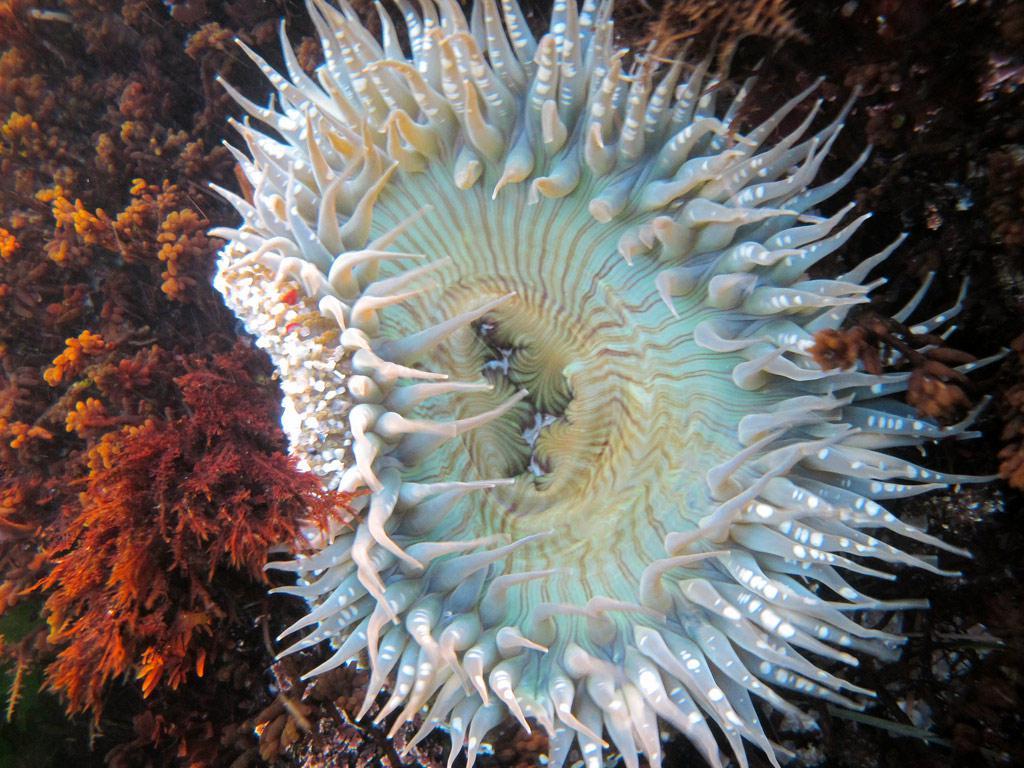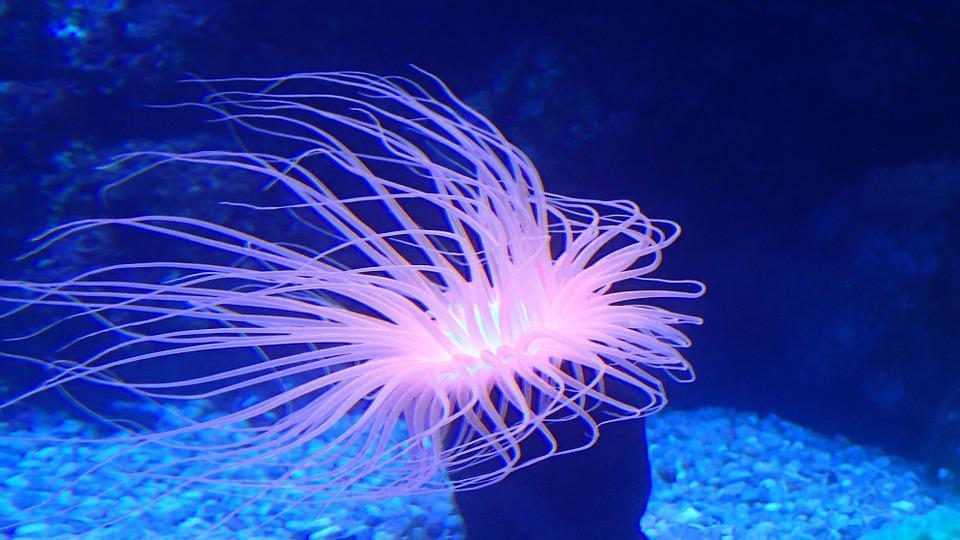The first image is the image on the left, the second image is the image on the right. Assess this claim about the two images: "The left image shows a white anemone with its mouth-like center visible.". Correct or not? Answer yes or no. Yes. The first image is the image on the left, the second image is the image on the right. For the images shown, is this caption "The trunk of the anemone can be seen in the image on the left." true? Answer yes or no. No. 